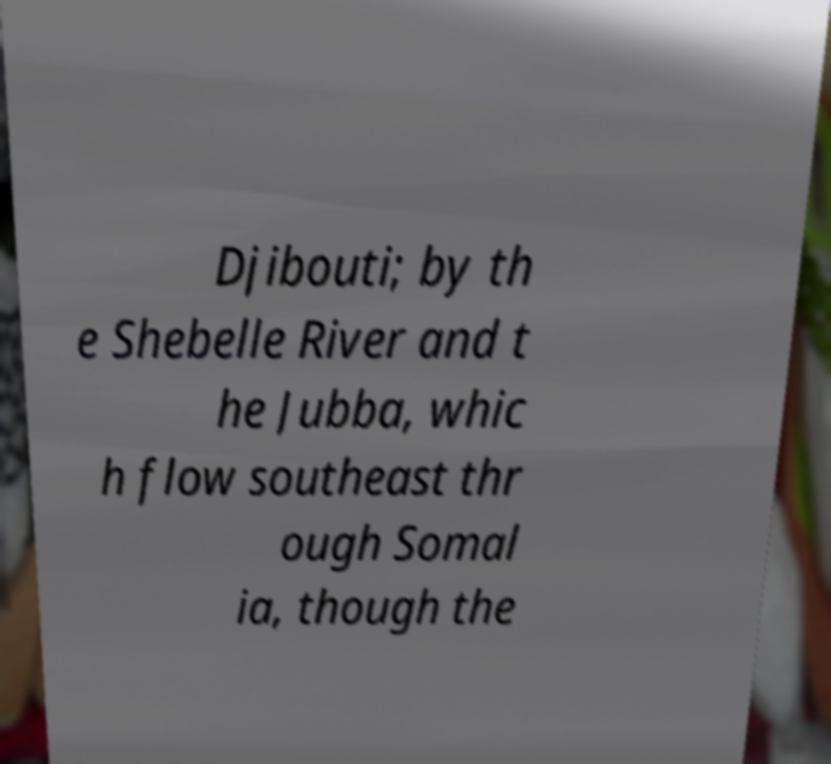Please read and relay the text visible in this image. What does it say? Djibouti; by th e Shebelle River and t he Jubba, whic h flow southeast thr ough Somal ia, though the 